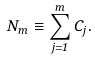<formula> <loc_0><loc_0><loc_500><loc_500>N _ { m } \equiv \sum ^ { m } _ { j = 1 } C _ { j } .</formula> 